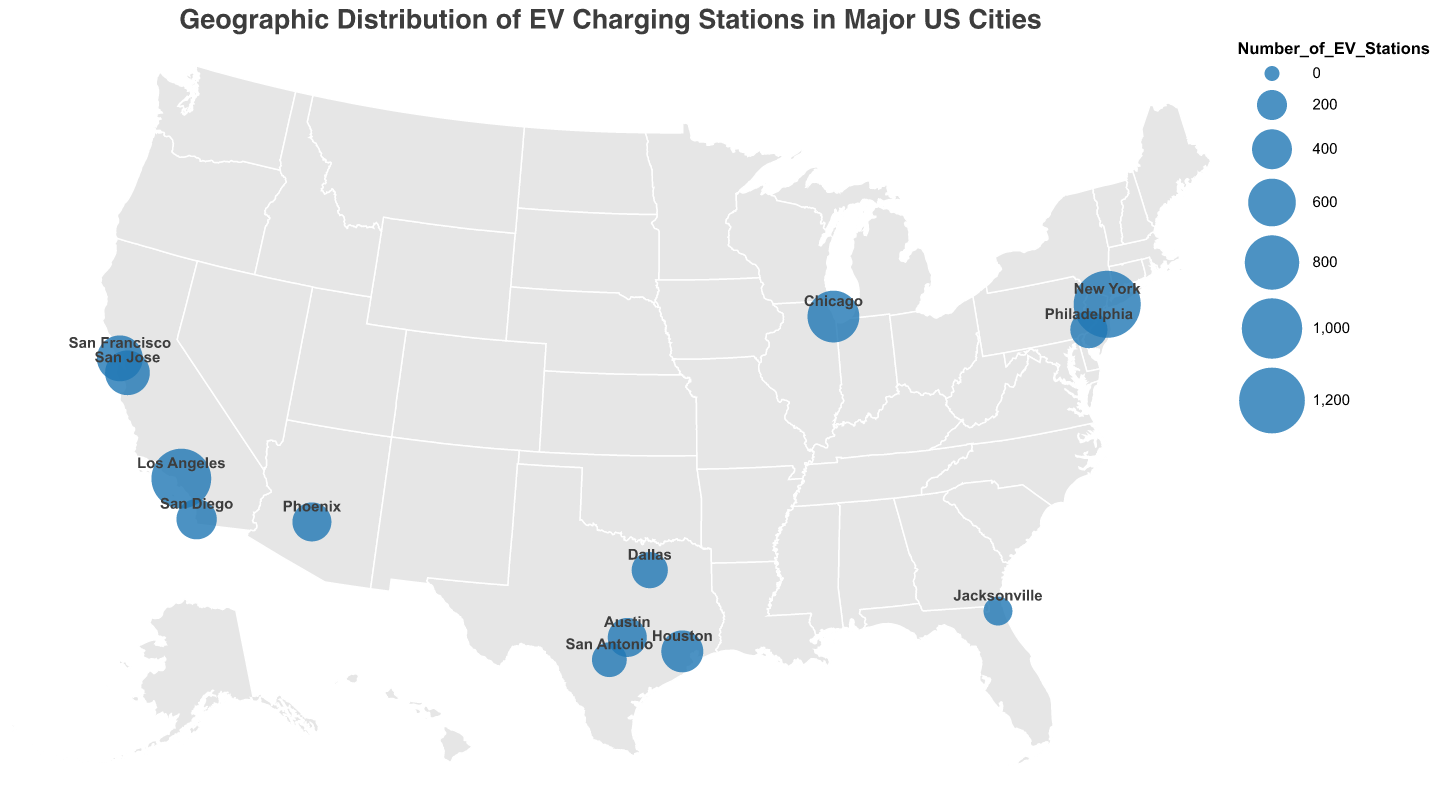Which city has the most EV charging stations? According to the figure, the city with the largest circle represents the highest number of EV charging stations. The tooltip for New York shows 1,250 stations, which is the highest.
Answer: New York Which city has the least percentage of total EV stations? The smallest percentages of total EV stations can be compared using the tooltips. Jacksonville's tooltip indicates 2.7%, which is the smallest percentage.
Answer: Jacksonville How many EV charging stations are there in Phoenix? By looking at the tooltip for Phoenix, it shows that the number of EV charging stations is 380.
Answer: 380 What is the title of the geographic plot? The title is shown at the top of the figure, which states "Geographic Distribution of EV Charging Stations in Major US Cities".
Answer: Geographic Distribution of EV Charging Stations in Major US Cities Which city has a higher number of EV charging stations, San Francisco or San Jose? The tooltips for both cities need to be compared. San Francisco has 550 EV stations and San Jose has 520.
Answer: San Francisco Which cities have more than 10% of the total EV stations? By reviewing the percentage of total EV stations from the tooltips of each city, New York (18.5%) and Los Angeles (14.5%) meet this criterion.
Answer: New York, Los Angeles What is the combined number of EV charging stations for Chicago and Houston? Summing the number of EV charging stations from the tooltips for Chicago (720) and Houston (450) gives the total: 720 + 450 = 1170.
Answer: 1,170 What is the median number of EV charging stations among all cities? Listing the numbers and finding the middle value: 180, 290, 320, 340, 380, 380, 410, 450, 520, 550, 720, 980, 1250. The middle value (7th) in this ordered list is 410.
Answer: 410 Name the cities that have the same number of EV charging stations. By comparing the values from the tooltips, Phoenix and Austin both have 380 EV stations.
Answer: Phoenix, Austin Which region (East or West) of the USA generally has more EV charging stations? Observing the circle sizes and their frequency on the geographic plot, more large circles (high numbers of EV stations) appear in the East than in the West.
Answer: East 